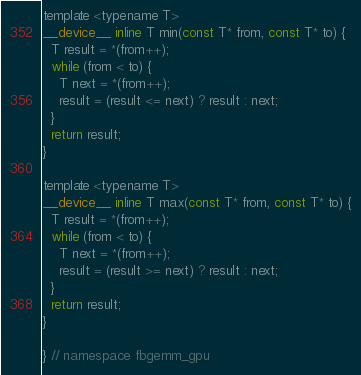<code> <loc_0><loc_0><loc_500><loc_500><_Cuda_>template <typename T>
__device__ inline T min(const T* from, const T* to) {
  T result = *(from++);
  while (from < to) {
    T next = *(from++);
    result = (result <= next) ? result : next;
  }
  return result;
}

template <typename T>
__device__ inline T max(const T* from, const T* to) {
  T result = *(from++);
  while (from < to) {
    T next = *(from++);
    result = (result >= next) ? result : next;
  }
  return result;
}

} // namespace fbgemm_gpu
</code> 